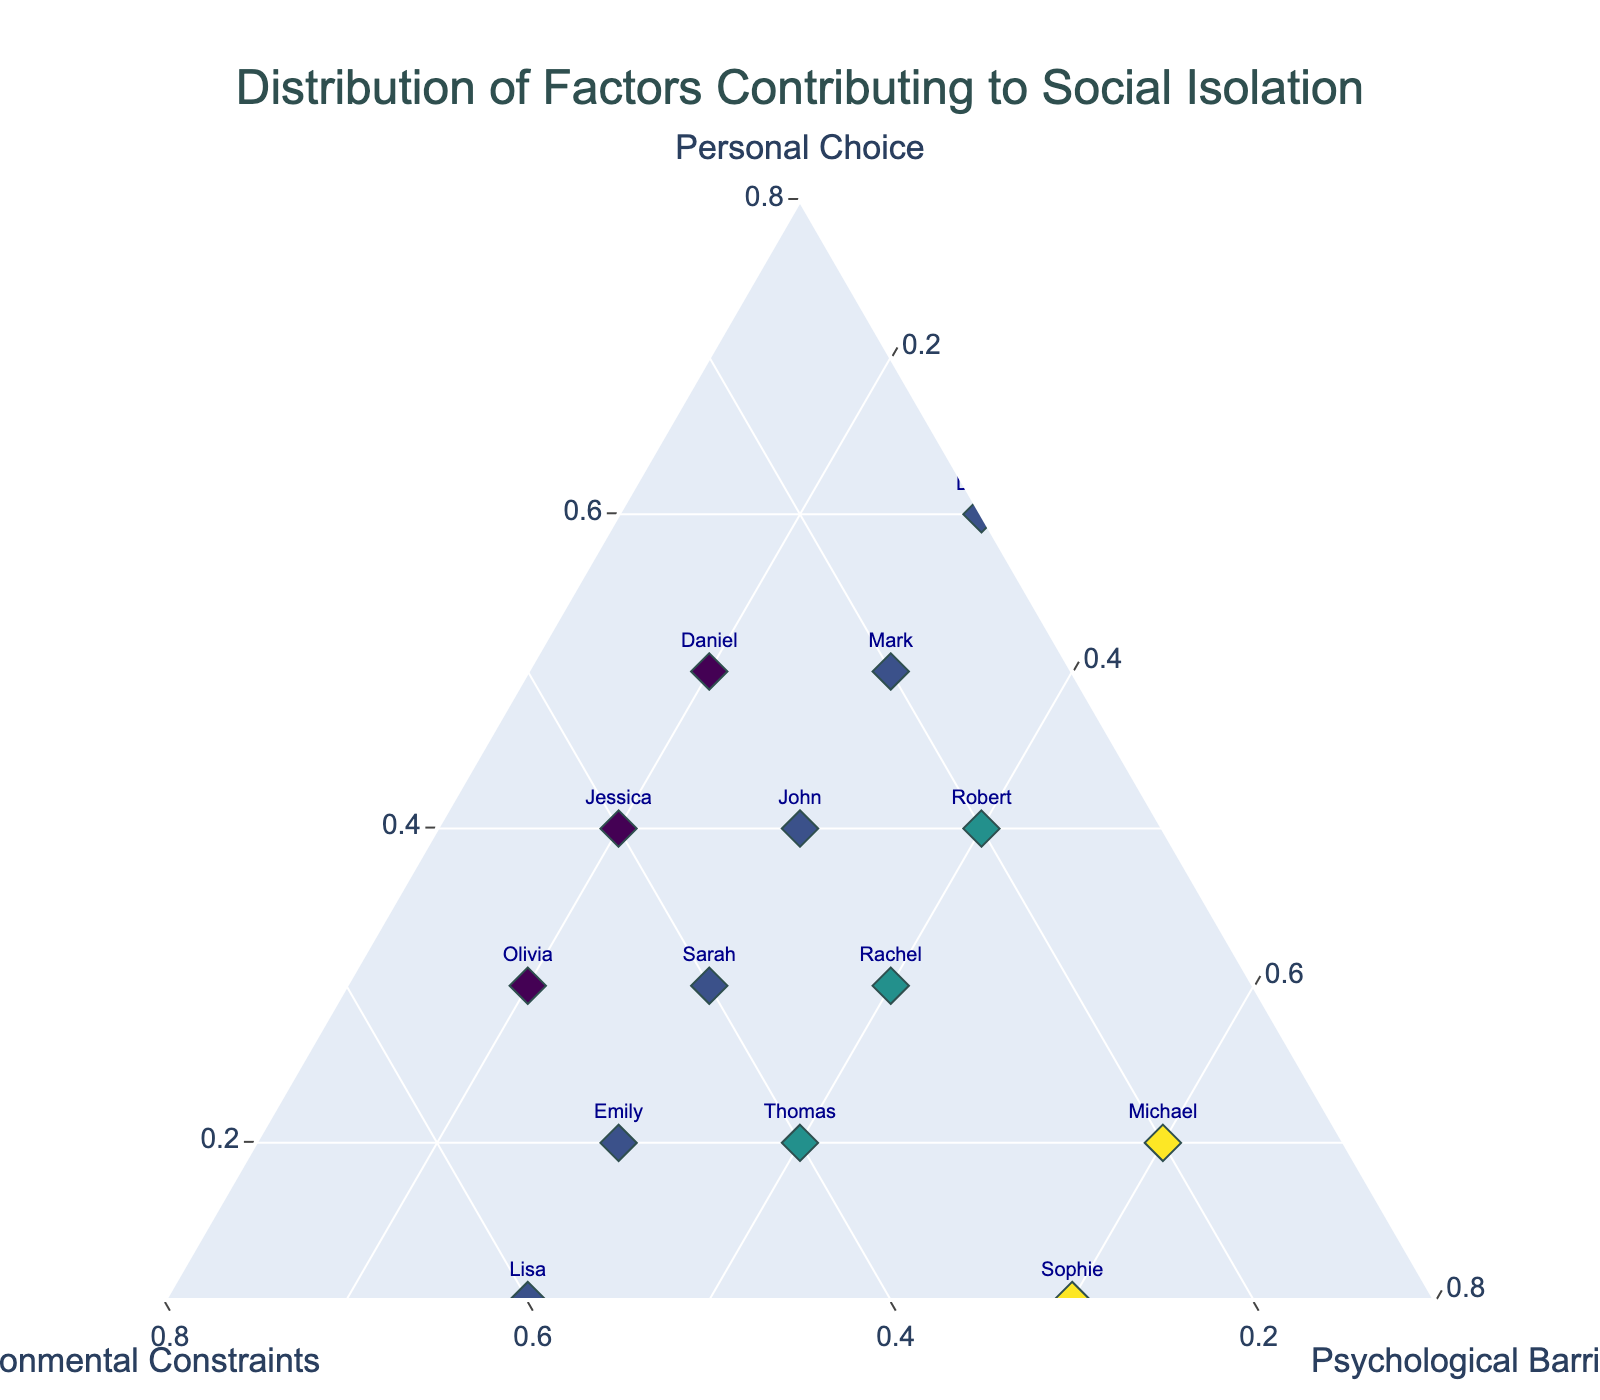What's the title of the plot? The title is placed at the top of the figure. By reading it, we can easily determine the figure's title.
Answer: Distribution of Factors Contributing to Social Isolation How many clients are represented in the plot? Each client is represented by a marker in the plot. By counting all the markers, we find the total number of clients. There are 14 clients listed in the initial data.
Answer: 14 Which client has the highest contribution from Psychological Barriers? Psychological Barriers are plotted along one of the ternary plot's axes. By identifying the client positioned closest to the Psychological Barriers axis, we find that Michael has the highest contribution value of 0.6.
Answer: Michael Which clients have equal contributions from Personal Choice and Environmental Constraints? We need to look for clients whose markers are positioned where the values of Personal Choice and Environmental Constraints are equal. Inspecting the plot, Rachel with values (0.3, 0.3) satisfies this condition.
Answer: Rachel What is the sum of contributions from Personal Choice for Sarah and David? Sarah's Personal Choice contribution is 0.3, and David's is 0.6. Summing them up, 0.3 + 0.6 = 0.9.
Answer: 0.9 Which client's marker is closest to Sarah's marker? To determine this, we identify the marker closest to Sarah's on the plot based on the ternary coordinates. John's marker, with values (0.4, 0.3, 0.3), is closest to Sarah's values (0.3, 0.4, 0.3).
Answer: John What is the average contribution from Environmental Constraints across all clients? Summing the Environmental Constraints contributions:  0.4 + 0.2 + 0.5 + 0.3 + 0.6 + 0.1 + 0.3 + 0.2 + 0.4 + 0.3 + 0.5 + 0.4 + 0.3 + 0.2 = 4.5, and dividing by the total number of clients (14), we get 4.5 / 14 ≈ 0.321.
Answer: 0.321 Compare the contributions from Personal Choice for Emily and Thomas. Who has a lower contribution? Emily has a Personal Choice contribution of 0.2, while Thomas has 0.2 as well. They both have equal contributions from Personal Choice.
Answer: Same What is the difference in contributions from Psychological Barriers between Michael and Sophie? Michael's Psychological Barriers contribution is 0.6, while Sophie's is also 0.6. The difference is 0.6 - 0.6 = 0.0.
Answer: 0.0 Which client has the highest total of contributions from all three factors? For each client, sum the values of their three factors and compare. For example, consider David's total (0.6 + 0.1 + 0.3 = 1.0). After evaluating all clients, we find that all clients sum to 1 due to the nature of the ternary plot where the sum of all factors is constrained to 1.
Answer: All clients have the same total 